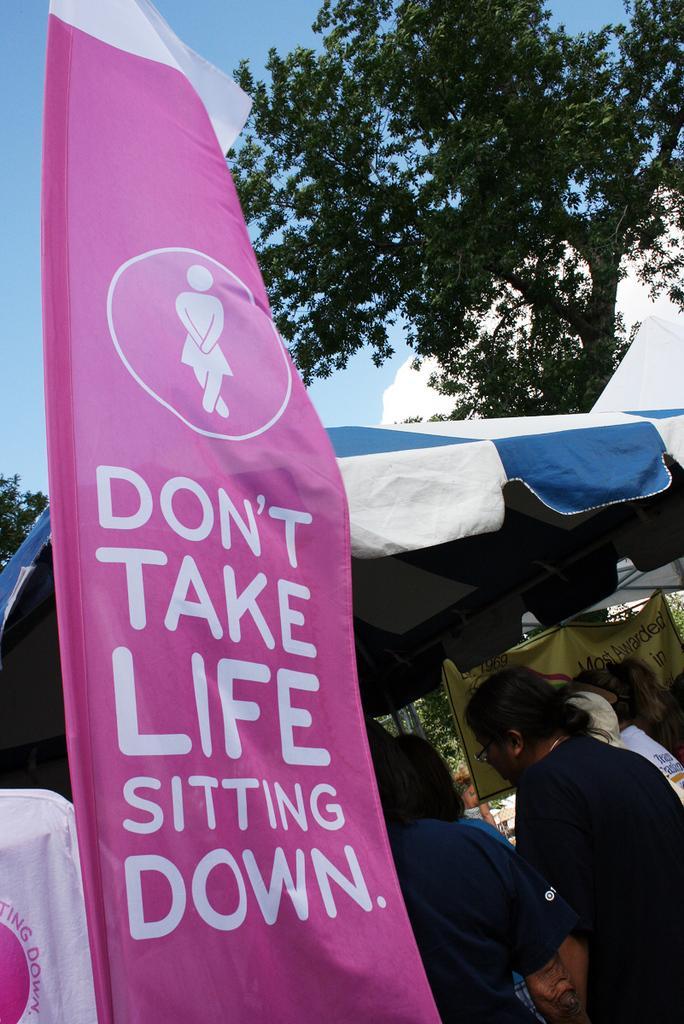Could you give a brief overview of what you see in this image? On the left side of the image we can see a poster on which some text was written. On the right side of the image we can see some ladies, a tent and a tree. 